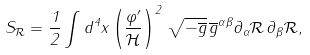<formula> <loc_0><loc_0><loc_500><loc_500>S _ { \mathcal { R } } = \frac { 1 } { 2 } \int d ^ { 4 } x \left ( \frac { \varphi ^ { \prime } } { \mathcal { H } } \right ) ^ { 2 } \, \sqrt { - \overline { g } } \, \overline { g } ^ { \alpha \beta } \partial _ { \alpha } { \mathcal { R } } \, \partial _ { \beta } { \mathcal { R } } ,</formula> 